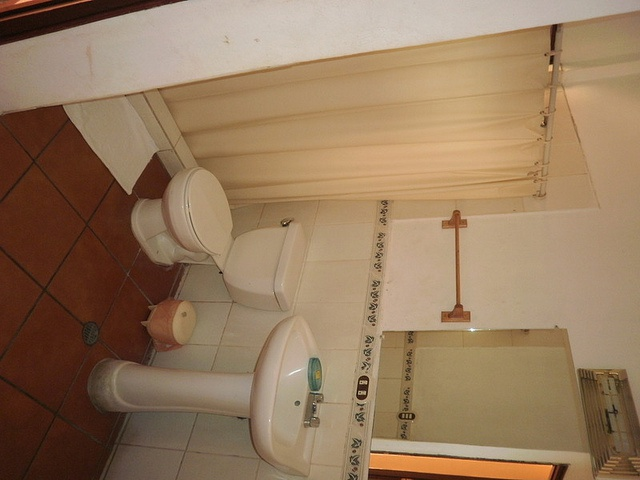Describe the objects in this image and their specific colors. I can see toilet in maroon, tan, and gray tones and sink in maroon, tan, and gray tones in this image. 